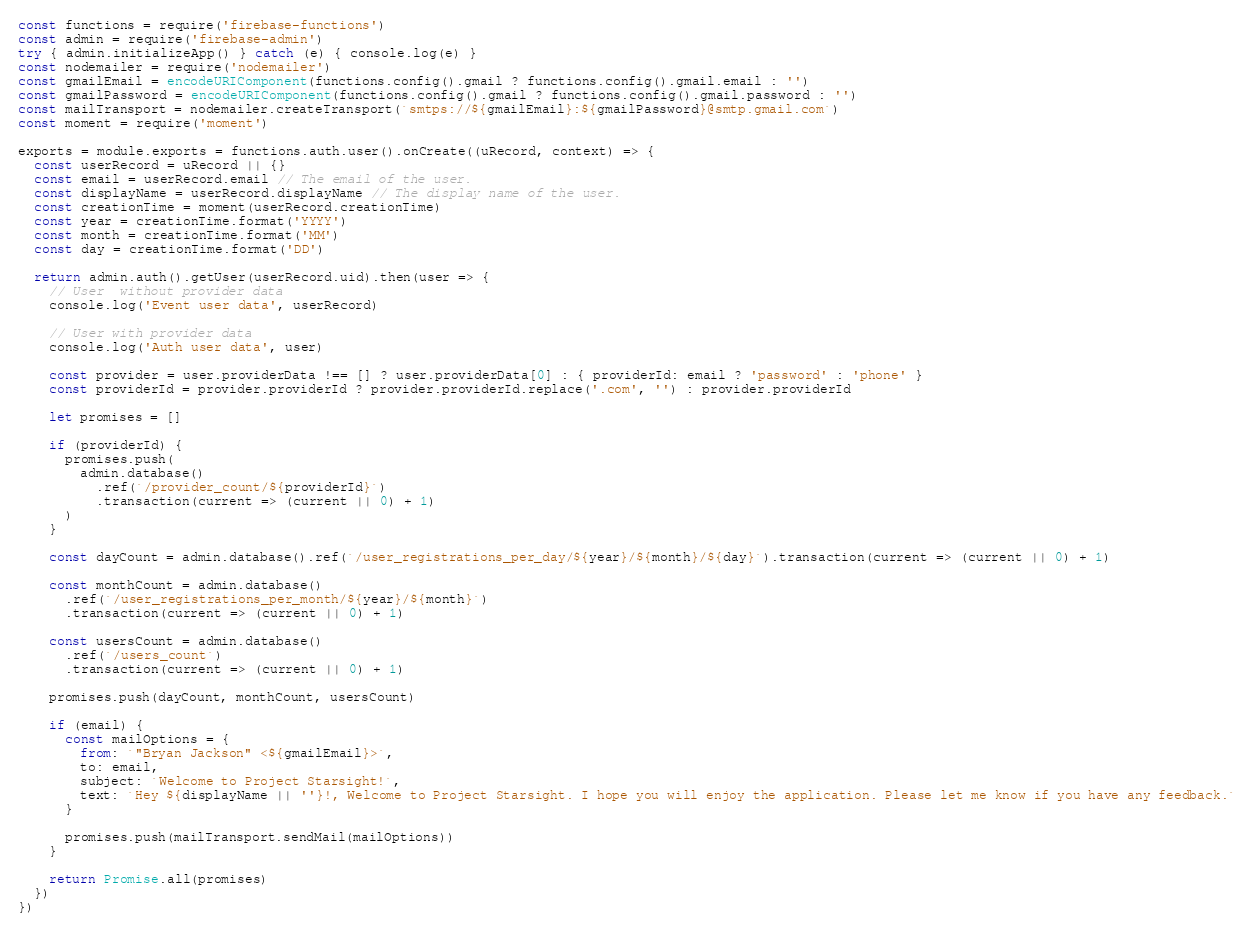Convert code to text. <code><loc_0><loc_0><loc_500><loc_500><_JavaScript_>const functions = require('firebase-functions')
const admin = require('firebase-admin')
try { admin.initializeApp() } catch (e) { console.log(e) }
const nodemailer = require('nodemailer')
const gmailEmail = encodeURIComponent(functions.config().gmail ? functions.config().gmail.email : '')
const gmailPassword = encodeURIComponent(functions.config().gmail ? functions.config().gmail.password : '')
const mailTransport = nodemailer.createTransport(`smtps://${gmailEmail}:${gmailPassword}@smtp.gmail.com`)
const moment = require('moment')

exports = module.exports = functions.auth.user().onCreate((uRecord, context) => {
  const userRecord = uRecord || {}
  const email = userRecord.email // The email of the user.
  const displayName = userRecord.displayName // The display name of the user.
  const creationTime = moment(userRecord.creationTime)
  const year = creationTime.format('YYYY')
  const month = creationTime.format('MM')
  const day = creationTime.format('DD')

  return admin.auth().getUser(userRecord.uid).then(user => {
    // User  without provider data
    console.log('Event user data', userRecord)

    // User with provider data
    console.log('Auth user data', user)

    const provider = user.providerData !== [] ? user.providerData[0] : { providerId: email ? 'password' : 'phone' }
    const providerId = provider.providerId ? provider.providerId.replace('.com', '') : provider.providerId

    let promises = []

    if (providerId) {
      promises.push(
        admin.database()
          .ref(`/provider_count/${providerId}`)
          .transaction(current => (current || 0) + 1)
      )
    }

    const dayCount = admin.database().ref(`/user_registrations_per_day/${year}/${month}/${day}`).transaction(current => (current || 0) + 1)

    const monthCount = admin.database()
      .ref(`/user_registrations_per_month/${year}/${month}`)
      .transaction(current => (current || 0) + 1)

    const usersCount = admin.database()
      .ref(`/users_count`)
      .transaction(current => (current || 0) + 1)

    promises.push(dayCount, monthCount, usersCount)

    if (email) {
      const mailOptions = {
        from: `"Bryan Jackson" <${gmailEmail}>`,
        to: email,
        subject: `Welcome to Project Starsight!`,
        text: `Hey ${displayName || ''}!, Welcome to Project Starsight. I hope you will enjoy the application. Please let me know if you have any feedback.`
      }

      promises.push(mailTransport.sendMail(mailOptions))
    }

    return Promise.all(promises)
  })
})
</code> 